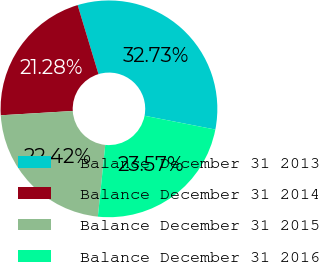Convert chart. <chart><loc_0><loc_0><loc_500><loc_500><pie_chart><fcel>Balance December 31 2013<fcel>Balance December 31 2014<fcel>Balance December 31 2015<fcel>Balance December 31 2016<nl><fcel>32.73%<fcel>21.28%<fcel>22.42%<fcel>23.57%<nl></chart> 